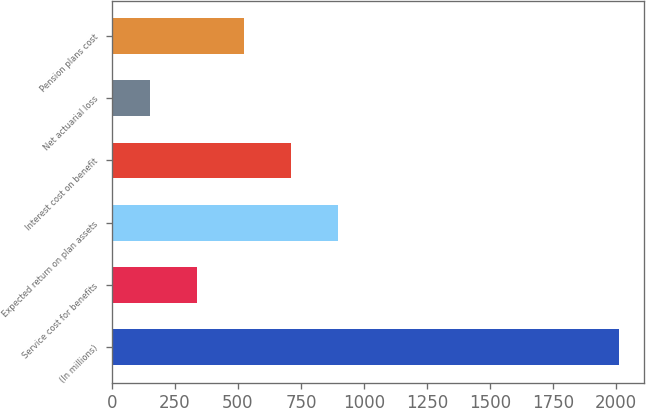<chart> <loc_0><loc_0><loc_500><loc_500><bar_chart><fcel>(In millions)<fcel>Service cost for benefits<fcel>Expected return on plan assets<fcel>Interest cost on benefit<fcel>Net actuarial loss<fcel>Pension plans cost<nl><fcel>2011<fcel>337<fcel>895<fcel>709<fcel>151<fcel>523<nl></chart> 